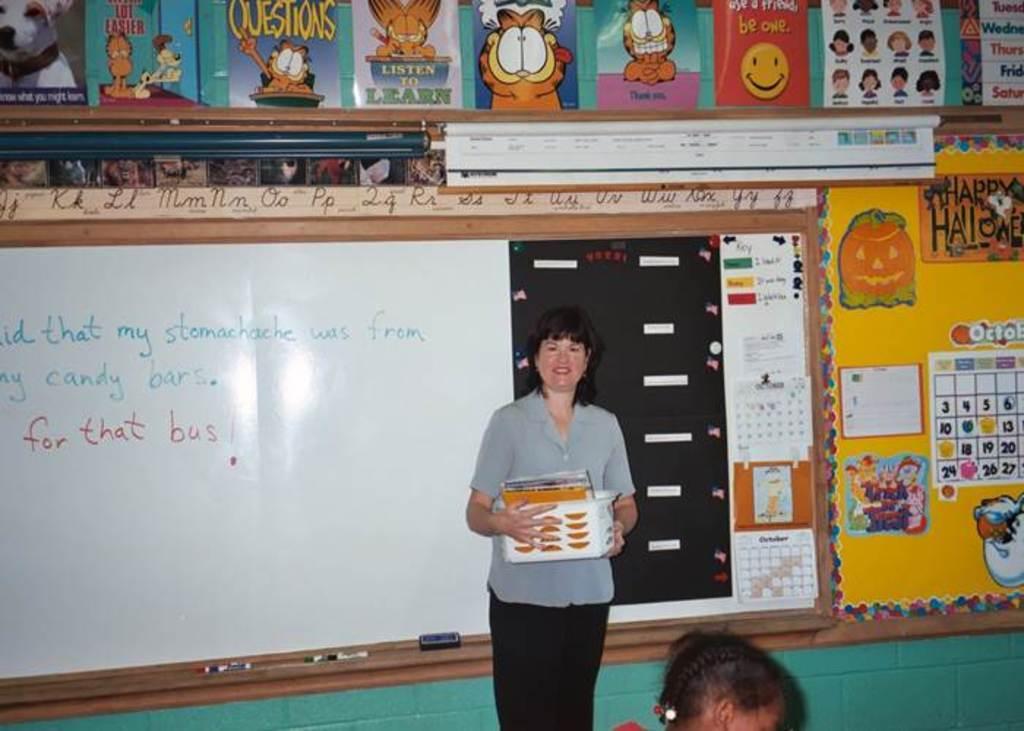Describe this image in one or two sentences. In the center of the image we can see a lady standing and holding a basket. At the bottom there is a person. In the background there is a board and we can see papers pasted on the wall. 